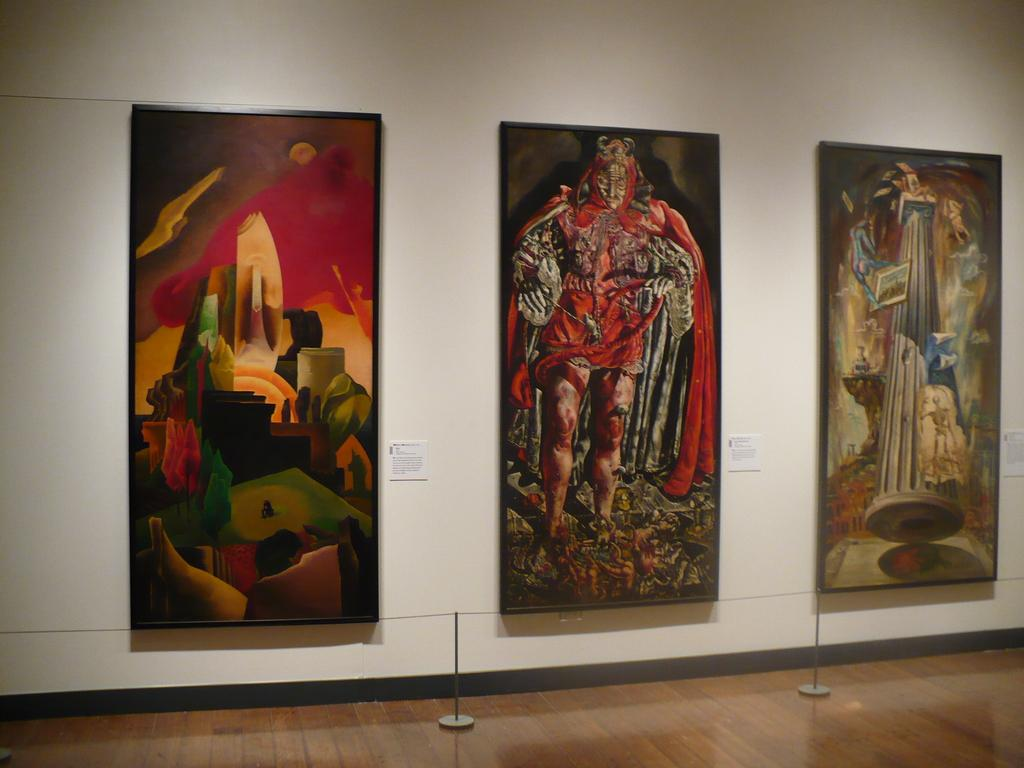What is the main feature in the center of the image? There is a wall in the center of the image. What is attached to the wall? There are photo frames and notes on the wall. What can be seen on the floor in the image? There are thin poles on the floor. How many toes can be seen on the wall in the image? There are no toes visible on the wall in the image. What type of request is being made in the image? There is no request present in the image; it only features a wall with photo frames and notes. 